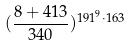Convert formula to latex. <formula><loc_0><loc_0><loc_500><loc_500>( \frac { 8 + 4 1 3 } { 3 4 0 } ) ^ { 1 9 1 ^ { 9 } \cdot 1 6 3 }</formula> 